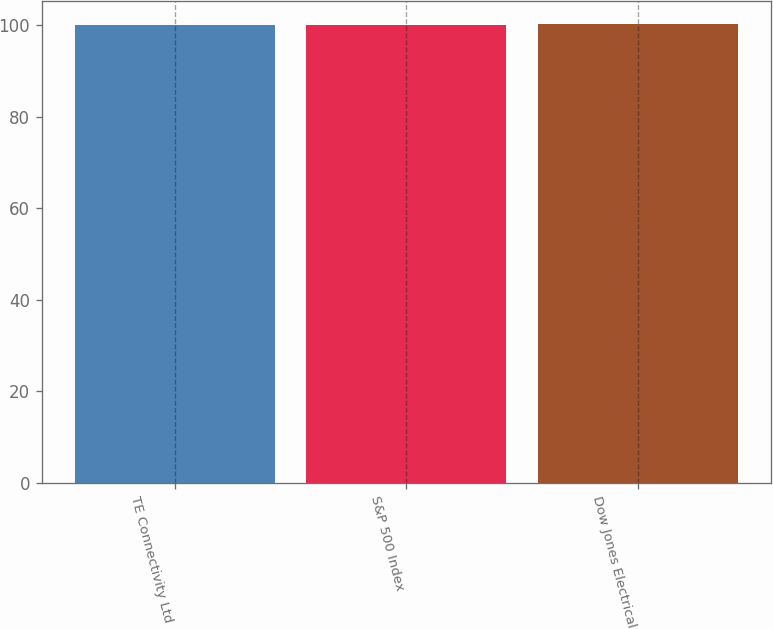Convert chart. <chart><loc_0><loc_0><loc_500><loc_500><bar_chart><fcel>TE Connectivity Ltd<fcel>S&P 500 Index<fcel>Dow Jones Electrical<nl><fcel>100<fcel>100.1<fcel>100.2<nl></chart> 